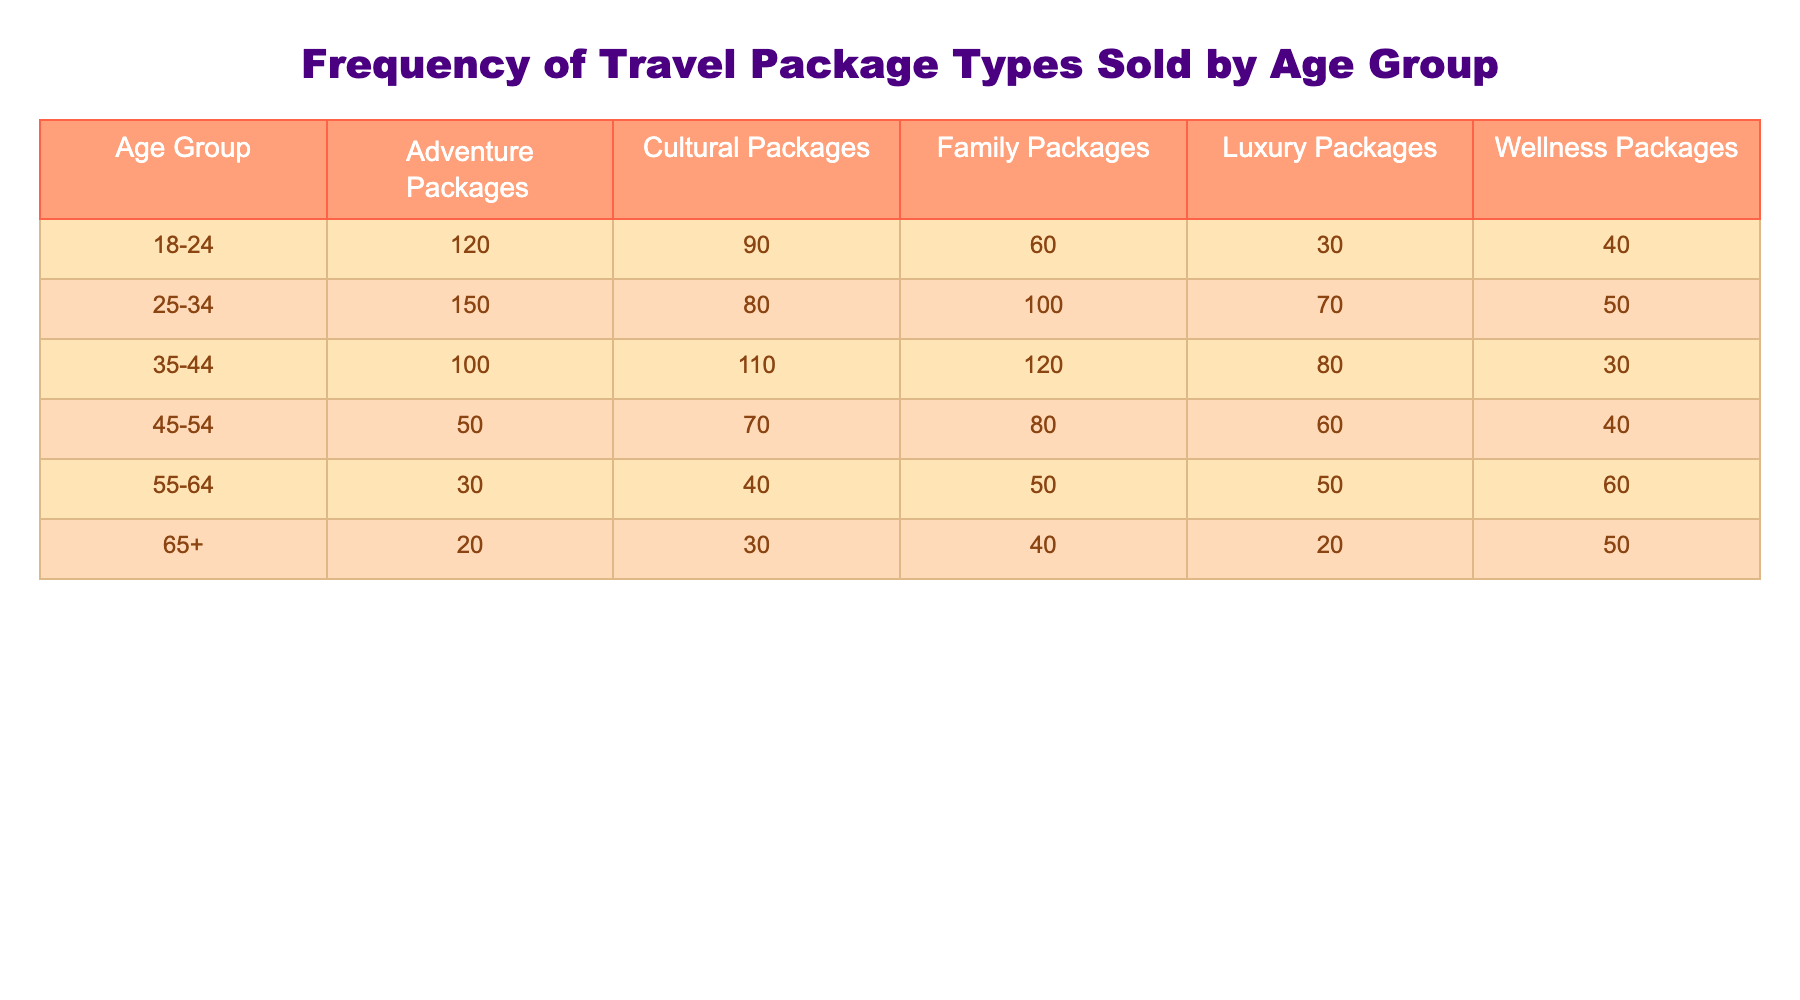What is the highest number of Adventure Packages sold, and which age group does it belong to? In the Adventure Packages column, the highest value is 150, which is under the age group 25-34.
Answer: 150, 25-34 How many Cultural Packages were sold to the 35-44 age group? Referring to the Cultural Packages column under the 35-44 age group, the value is 110.
Answer: 110 What is the total number of Family Packages sold across all age groups? To find the total, we add the Family Packages: 60 + 100 + 120 + 80 + 50 + 40 = 450.
Answer: 450 Are more Luxury Packages sold to the 45-54 age group compared to the 55-64 age group? The 45-54 age group has 60 Luxury Packages, and the 55-64 age group has 50. Since 60 is greater than 50, the statement is true.
Answer: Yes What is the average number of Wellness Packages sold across all age groups? We sum the Wellness Packages: 40 + 50 + 30 + 40 + 60 + 50 = 270. There are 6 age groups, so we divide: 270/6 = 45.
Answer: 45 What age group sold the least number of Adventure Packages, and how many were sold? Checking the Adventure Packages column, the 65+ age group sold the least at 20 packages.
Answer: 65+, 20 How do the Wellness Packages sold to the 66+ age group compare to those sold in the 25-34 age group? The 65+ age group sold 50 Wellness Packages and the 25-34 age group sold 50 as well; they are equal, resulting in a comparison showing no difference.
Answer: Equal What is the difference in total sales between the Adventure Packages and Cultural Packages for the 18-24 age group? For the 18-24 age group, Adventure Packages sold 120 and Cultural Packages 90. The difference is 120 - 90 = 30.
Answer: 30 Which age group has more packages sold overall, the 35-44 or the 45-54 age group? For the 35-44 age group, the total is 100 + 110 + 120 + 80 + 30 = 440. For the 45-54 age group, it is 50 + 70 + 80 + 60 + 40 = 300. Comparing 440 with 300 shows the 35-44 age group has more.
Answer: 35-44 